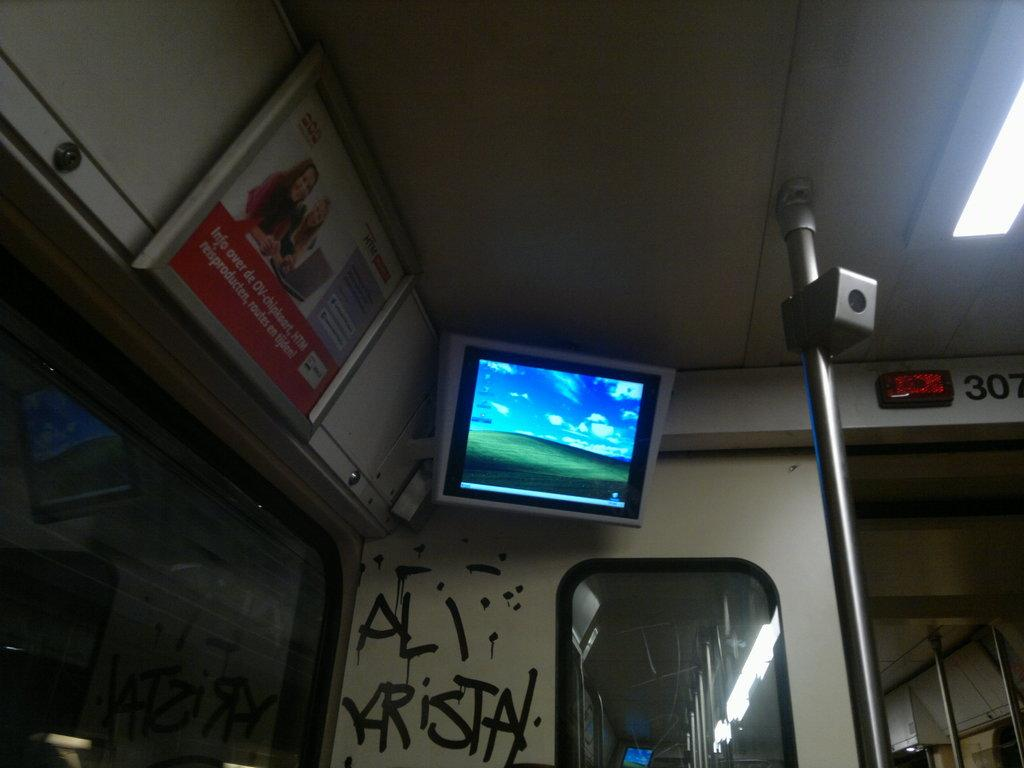Provide a one-sentence caption for the provided image. bus or train with a screen tv in the corner wall. 